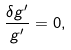Convert formula to latex. <formula><loc_0><loc_0><loc_500><loc_500>\frac { \delta g ^ { \prime } } { g ^ { \prime } } = 0 ,</formula> 